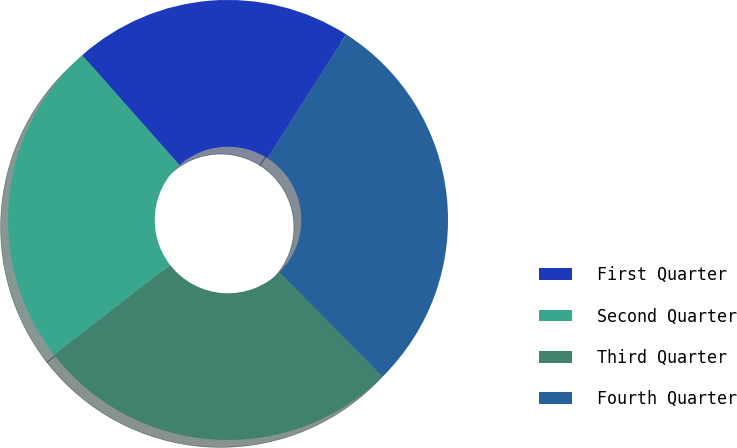Convert chart to OTSL. <chart><loc_0><loc_0><loc_500><loc_500><pie_chart><fcel>First Quarter<fcel>Second Quarter<fcel>Third Quarter<fcel>Fourth Quarter<nl><fcel>20.56%<fcel>23.98%<fcel>26.89%<fcel>28.58%<nl></chart> 